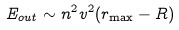Convert formula to latex. <formula><loc_0><loc_0><loc_500><loc_500>E _ { o u t } \sim n ^ { 2 } v ^ { 2 } ( r _ { \max } - R )</formula> 